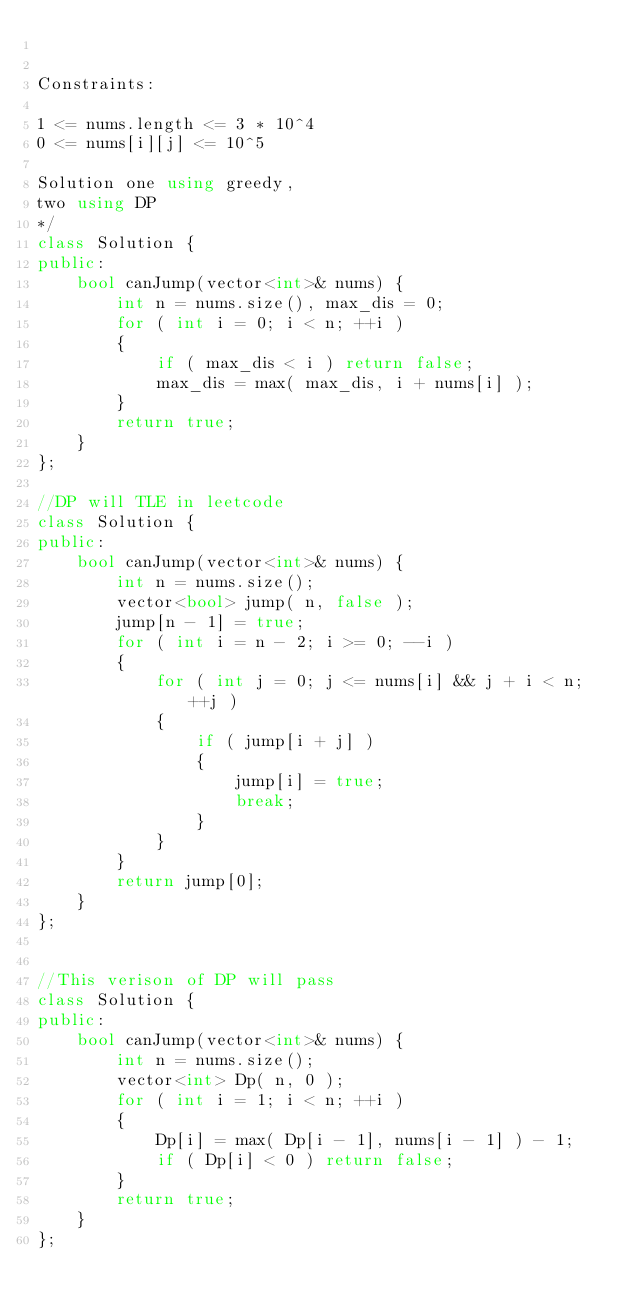<code> <loc_0><loc_0><loc_500><loc_500><_C++_>

Constraints:

1 <= nums.length <= 3 * 10^4
0 <= nums[i][j] <= 10^5

Solution one using greedy,
two using DP
*/
class Solution {
public:
    bool canJump(vector<int>& nums) {
        int n = nums.size(), max_dis = 0;
        for ( int i = 0; i < n; ++i )
        {
            if ( max_dis < i ) return false;
            max_dis = max( max_dis, i + nums[i] );
        }
        return true;
    }
};

//DP will TLE in leetcode
class Solution {
public:
    bool canJump(vector<int>& nums) {
        int n = nums.size();
        vector<bool> jump( n, false );
        jump[n - 1] = true;
        for ( int i = n - 2; i >= 0; --i )
        {
            for ( int j = 0; j <= nums[i] && j + i < n; ++j )
            {
                if ( jump[i + j] )
                {
                    jump[i] = true;
                    break;
                }
            }
        }
        return jump[0];
    }
};


//This verison of DP will pass
class Solution {
public:
    bool canJump(vector<int>& nums) {
        int n = nums.size();
        vector<int> Dp( n, 0 );
        for ( int i = 1; i < n; ++i )
        {
            Dp[i] = max( Dp[i - 1], nums[i - 1] ) - 1;
            if ( Dp[i] < 0 ) return false;
        }
        return true;
    }
};
</code> 